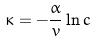<formula> <loc_0><loc_0><loc_500><loc_500>\kappa = - \frac { \alpha } { v } \ln c</formula> 